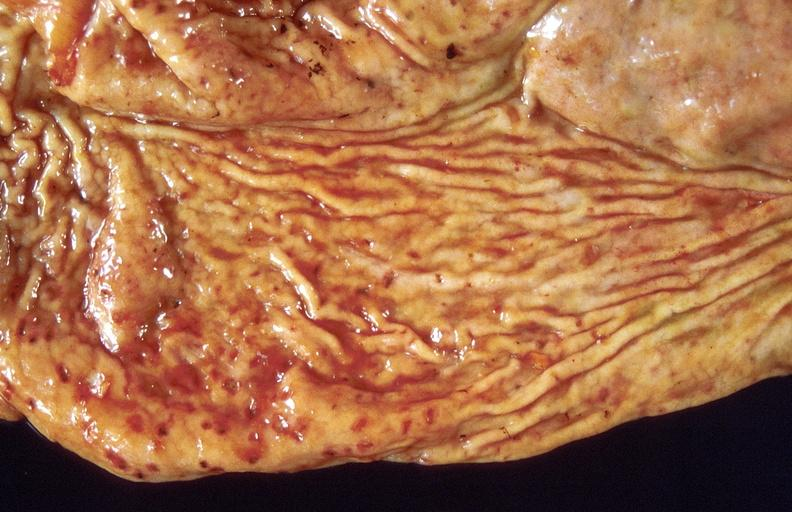s gastrointestinal present?
Answer the question using a single word or phrase. Yes 